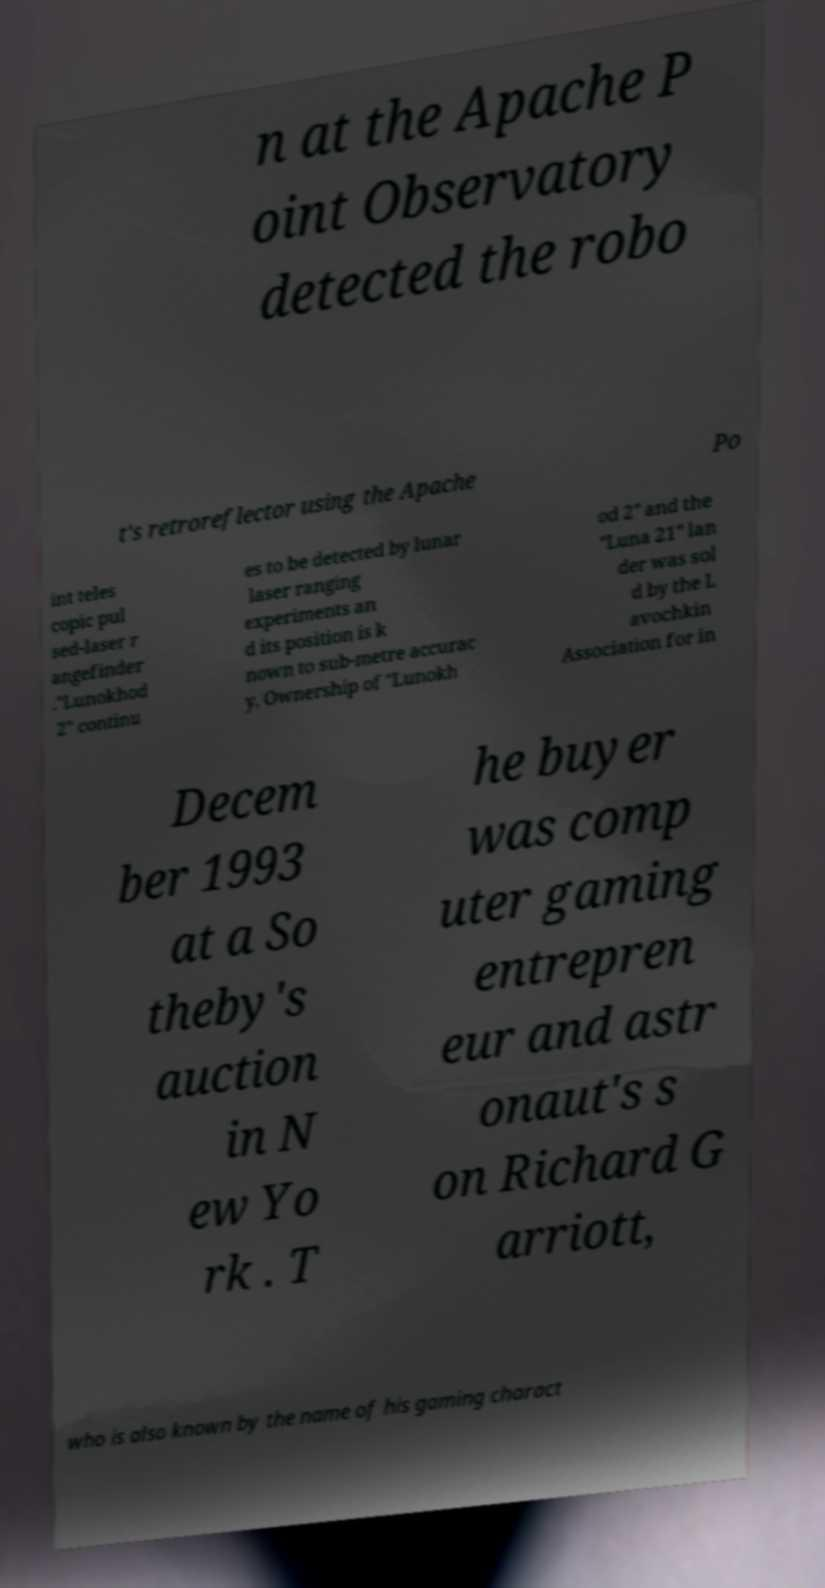Can you accurately transcribe the text from the provided image for me? n at the Apache P oint Observatory detected the robo t's retroreflector using the Apache Po int teles copic pul sed-laser r angefinder ."Lunokhod 2" continu es to be detected by lunar laser ranging experiments an d its position is k nown to sub-metre accurac y. Ownership of "Lunokh od 2" and the "Luna 21" lan der was sol d by the L avochkin Association for in Decem ber 1993 at a So theby's auction in N ew Yo rk . T he buyer was comp uter gaming entrepren eur and astr onaut's s on Richard G arriott, who is also known by the name of his gaming charact 